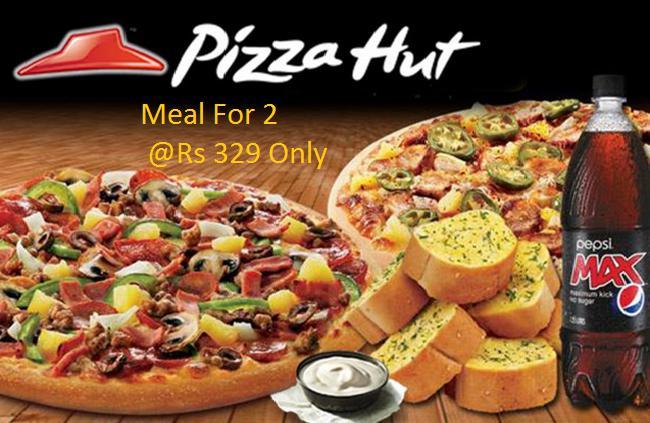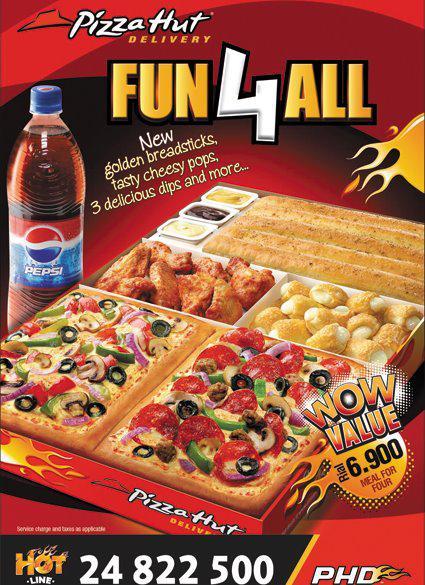The first image is the image on the left, the second image is the image on the right. Evaluate the accuracy of this statement regarding the images: "A single bottle of soda sits near pizza in the image on the right.". Is it true? Answer yes or no. Yes. The first image is the image on the left, the second image is the image on the right. Given the left and right images, does the statement "There are two bottles of soda pictured." hold true? Answer yes or no. Yes. 